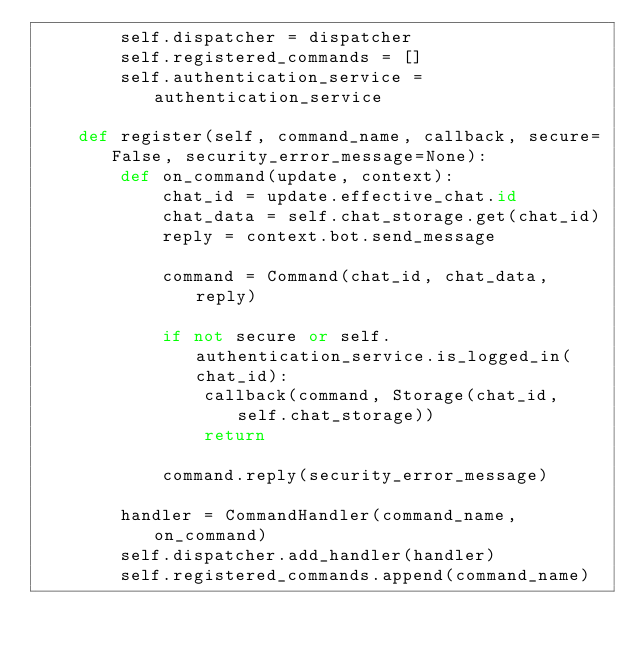Convert code to text. <code><loc_0><loc_0><loc_500><loc_500><_Python_>        self.dispatcher = dispatcher
        self.registered_commands = []
        self.authentication_service = authentication_service

    def register(self, command_name, callback, secure=False, security_error_message=None):
        def on_command(update, context):
            chat_id = update.effective_chat.id
            chat_data = self.chat_storage.get(chat_id)
            reply = context.bot.send_message

            command = Command(chat_id, chat_data, reply)

            if not secure or self.authentication_service.is_logged_in(chat_id):
                callback(command, Storage(chat_id, self.chat_storage))
                return
            
            command.reply(security_error_message)

        handler = CommandHandler(command_name, on_command)
        self.dispatcher.add_handler(handler)
        self.registered_commands.append(command_name)
</code> 